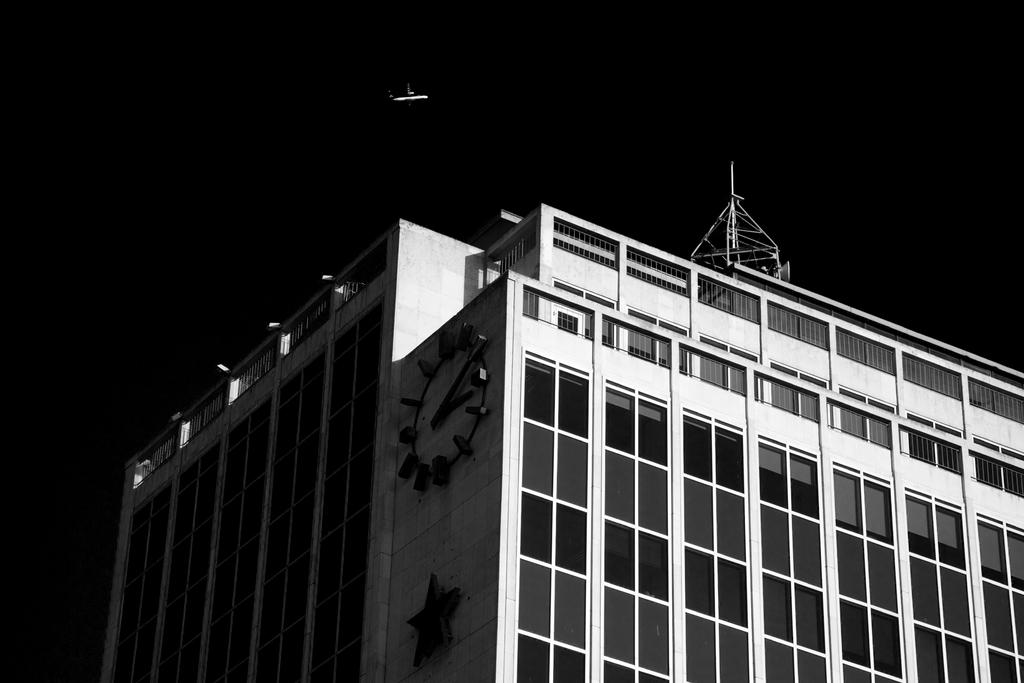What type of structure is visible in the image? There is a building in the image. What other feature can be seen on the building? There is a tower on the building. What is attached to the tower? There is a clock on the building. What else is present in the sky in the image? There is an airplane in the air. How would you describe the lighting in the image? The background of the image is dark. What type of lettuce is used to cover the building in the image? There is no lettuce present in the image, and the building is not covered by any lettuce. What event caused the airplane to fly in the image? The image does not provide information about the cause of the airplane's flight, so we cannot determine the reason for it. 